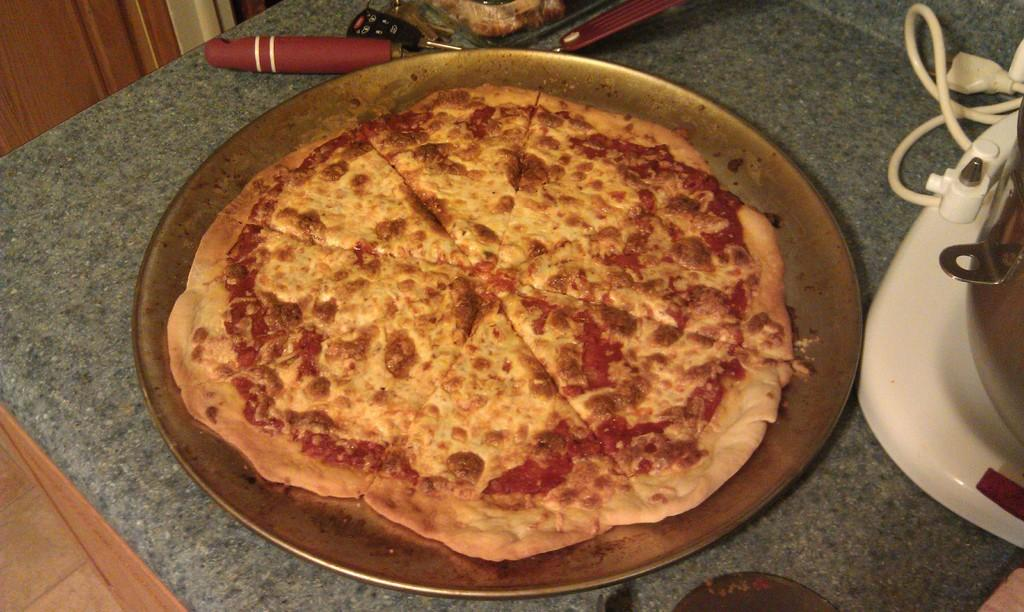What is on the plate in the image? There is food on a plate in the image. What else can be seen near the plate? There are objects beside the plate in the image. Can you describe the wooden object in the image? There is a wooden object in the top left of the image. What type of waves can be seen crashing on the shore in the image? There are no waves or shore visible in the image; it features food on a plate, objects beside the plate, and a wooden object. What degree of difficulty is the part of the image that shows the wooden object rated? The image does not have a difficulty rating, and there is no part of the image that can be rated. 